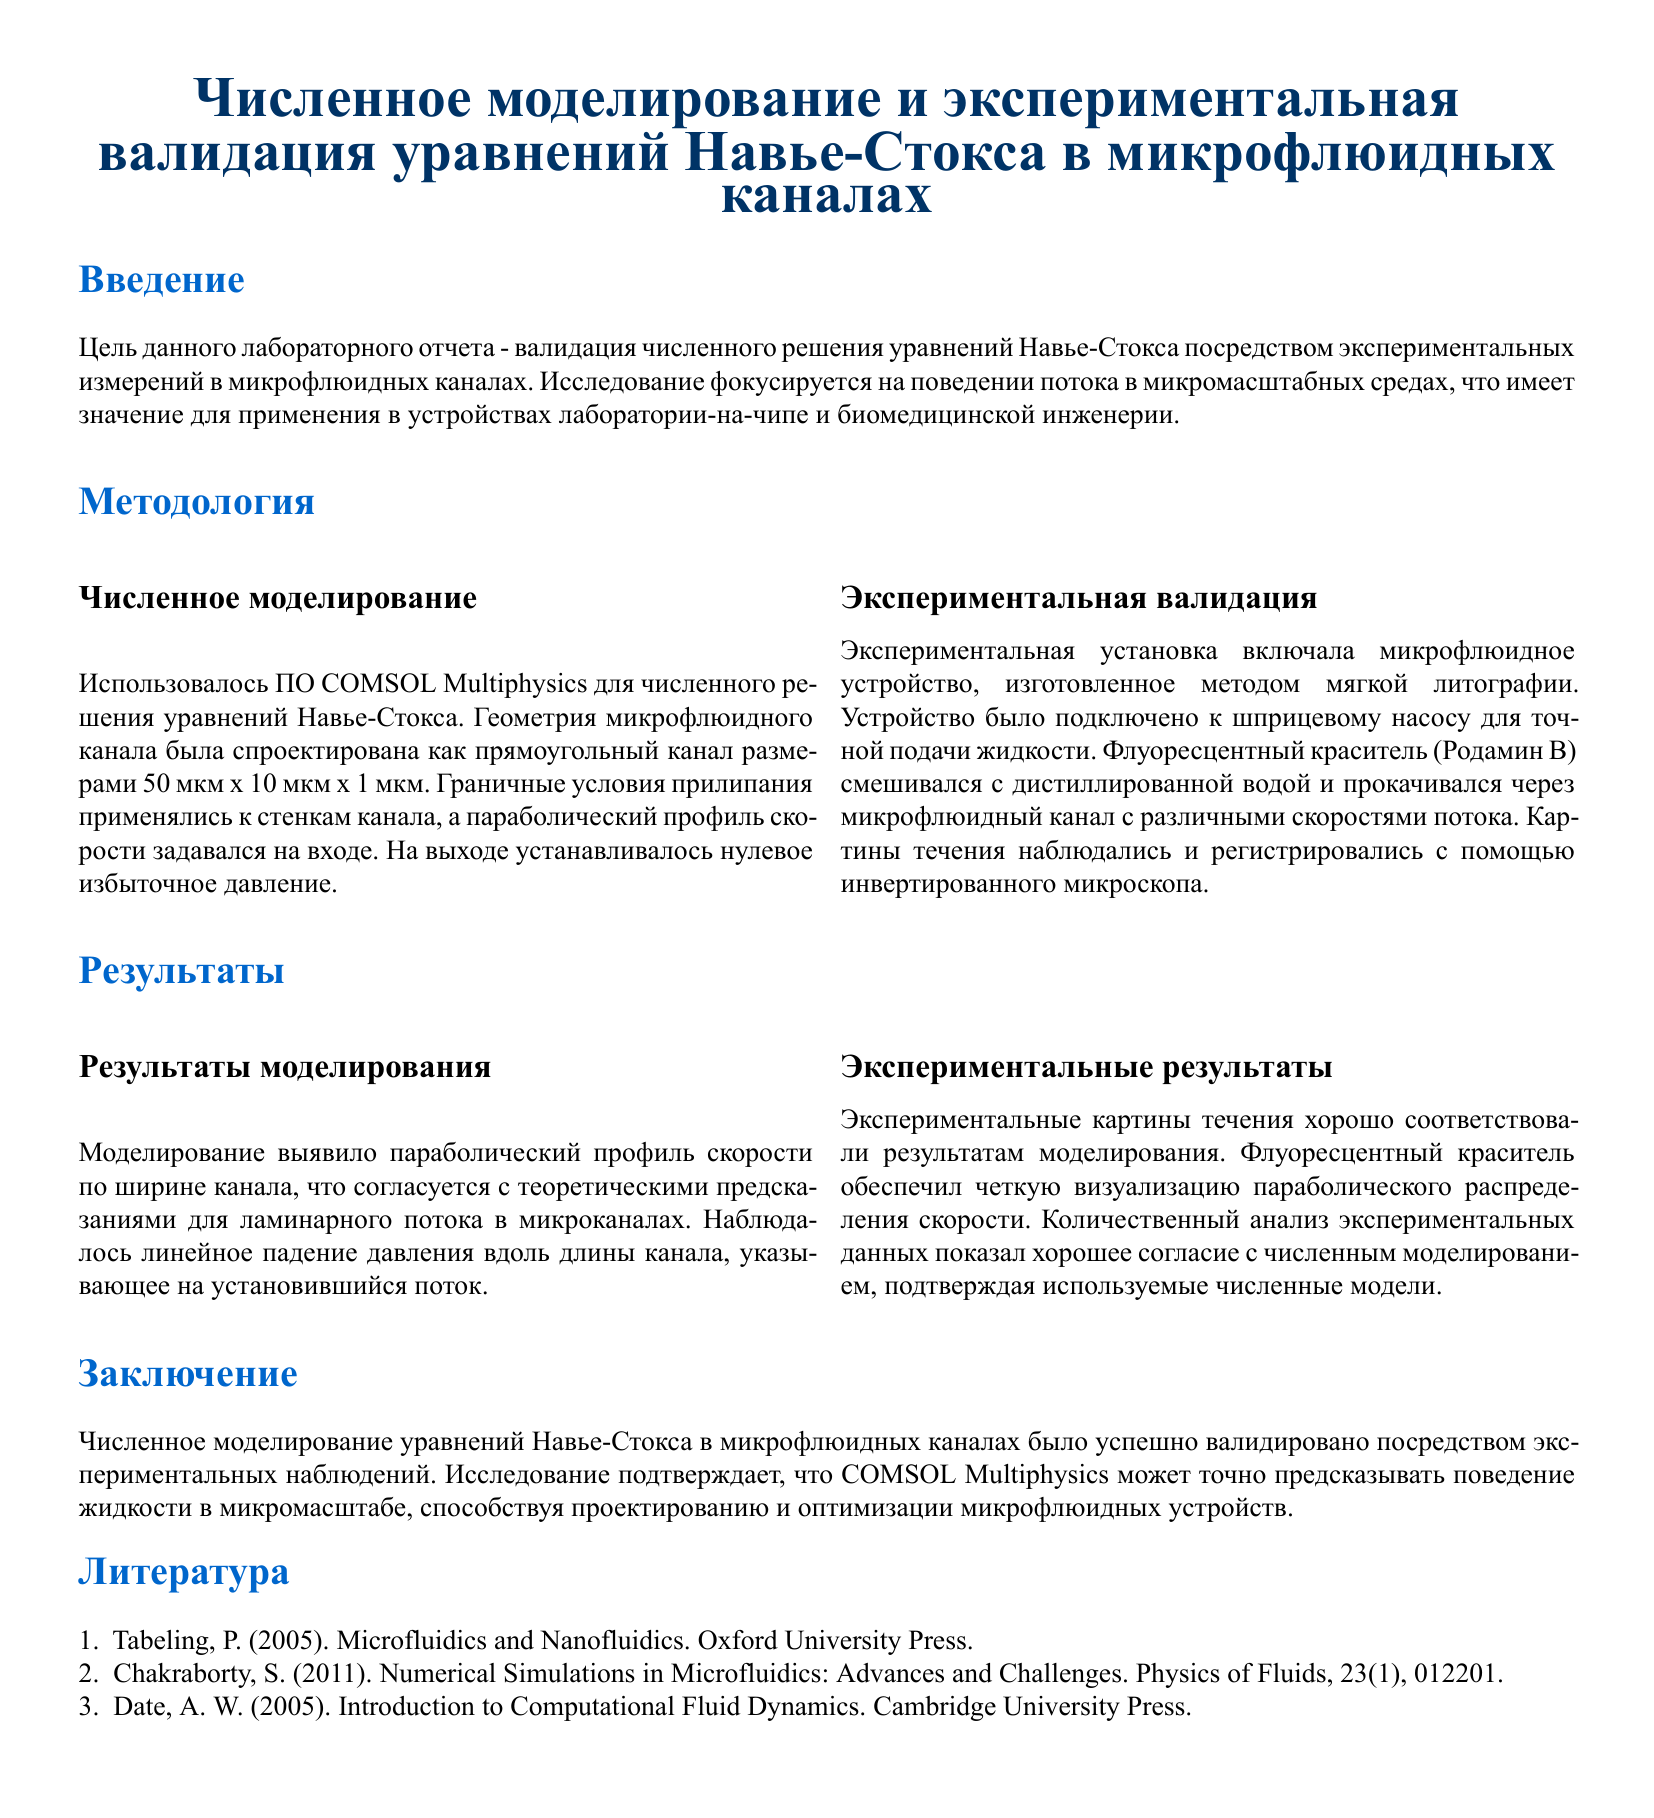Что является целью лабораторного отчета? Целью отчета является валидация численного решения уравнений Навье-Стокса через экспериментальные измерения.
Answer: Валидация численного решения Какой программный продукт использовался для численного моделирования? В документе указано, что использовалось ПО для численного решения уравнений.
Answer: COMSOL Multiphysics Какова длина микрофлюидного канала? В отчете указаны размеры канала, включая длину.
Answer: 50 мкм Какой метод изготовления использовался для микрофлюидного устройства? Указан метод, который был применен для изготовления устройства.
Answer: Мягкая литография Какой тип потока наблюдается в микрофлюидном канале? В результатах моделирования упоминается о характере потока.
Answer: Ламинарный Что использовалось для визуализации потока в эксперименте? В отчете описано, что использовалось для создания изображений течения.
Answer: Флуоресцентный краситель Какой тип анализ был проведен для сравнения данных? Указан метод анализа данных, используемый в эксперименте.
Answer: Количественный анализ Согласно отчету, что подтверждает точность численных моделей? В документе упоминается, что что-то подтвердило точность моделей.
Answer: Экспериментальные результаты Какова основная тема исследования, согласно заключению? Заключение подводит итог исследованиям в определенной области.
Answer: Микрофлюидные устройства 